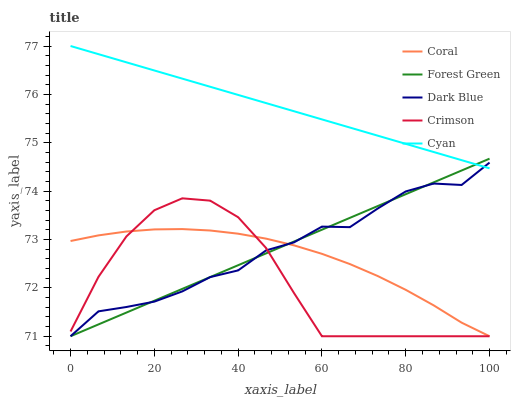Does Crimson have the minimum area under the curve?
Answer yes or no. Yes. Does Cyan have the maximum area under the curve?
Answer yes or no. Yes. Does Dark Blue have the minimum area under the curve?
Answer yes or no. No. Does Dark Blue have the maximum area under the curve?
Answer yes or no. No. Is Cyan the smoothest?
Answer yes or no. Yes. Is Dark Blue the roughest?
Answer yes or no. Yes. Is Coral the smoothest?
Answer yes or no. No. Is Coral the roughest?
Answer yes or no. No. Does Crimson have the lowest value?
Answer yes or no. Yes. Does Cyan have the lowest value?
Answer yes or no. No. Does Cyan have the highest value?
Answer yes or no. Yes. Does Dark Blue have the highest value?
Answer yes or no. No. Is Coral less than Cyan?
Answer yes or no. Yes. Is Cyan greater than Coral?
Answer yes or no. Yes. Does Crimson intersect Coral?
Answer yes or no. Yes. Is Crimson less than Coral?
Answer yes or no. No. Is Crimson greater than Coral?
Answer yes or no. No. Does Coral intersect Cyan?
Answer yes or no. No. 